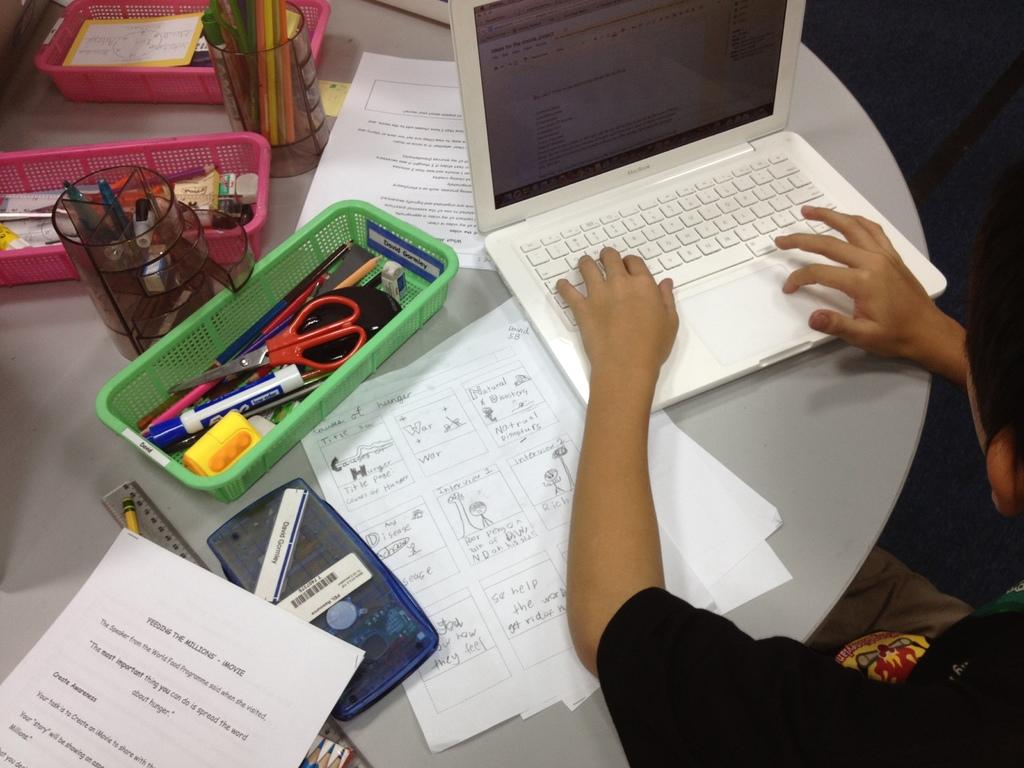<image>
Describe the image concisely. the letter H is on the white piece of paper 